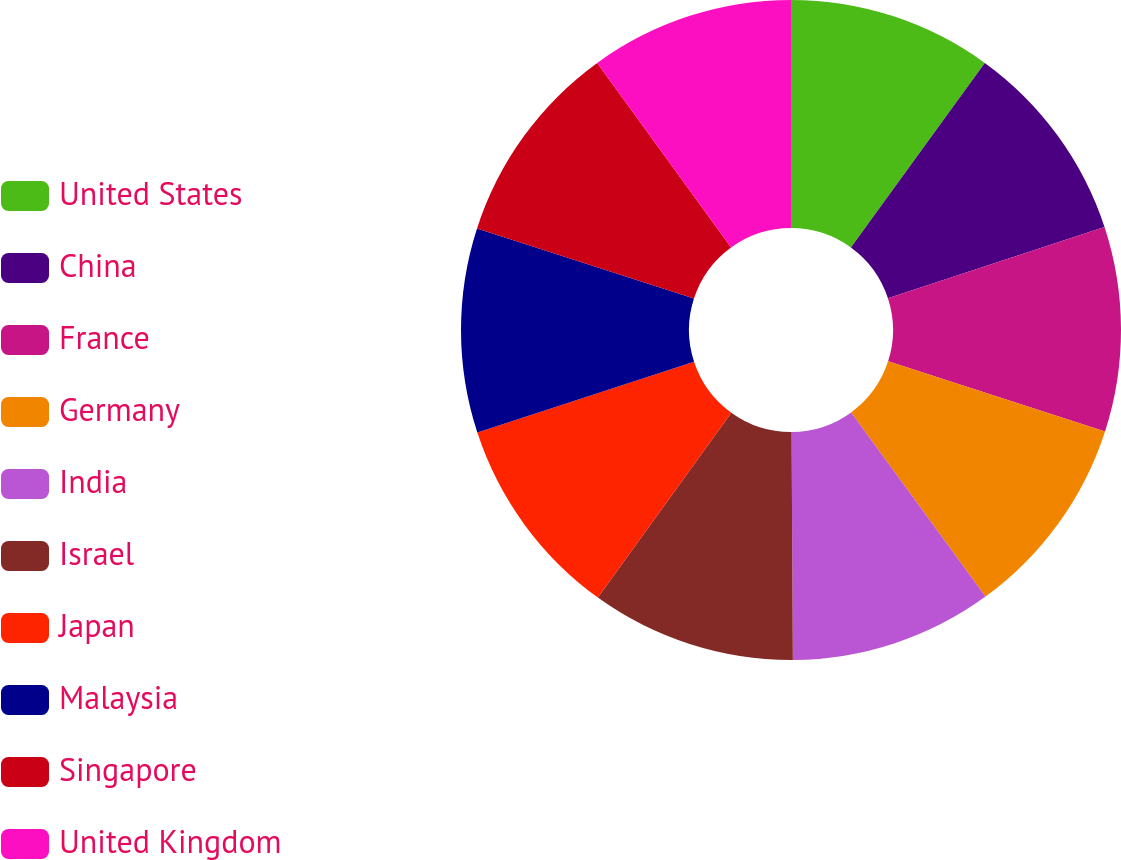<chart> <loc_0><loc_0><loc_500><loc_500><pie_chart><fcel>United States<fcel>China<fcel>France<fcel>Germany<fcel>India<fcel>Israel<fcel>Japan<fcel>Malaysia<fcel>Singapore<fcel>United Kingdom<nl><fcel>9.99%<fcel>9.96%<fcel>10.02%<fcel>10.0%<fcel>9.94%<fcel>10.04%<fcel>10.02%<fcel>10.01%<fcel>10.03%<fcel>9.99%<nl></chart> 